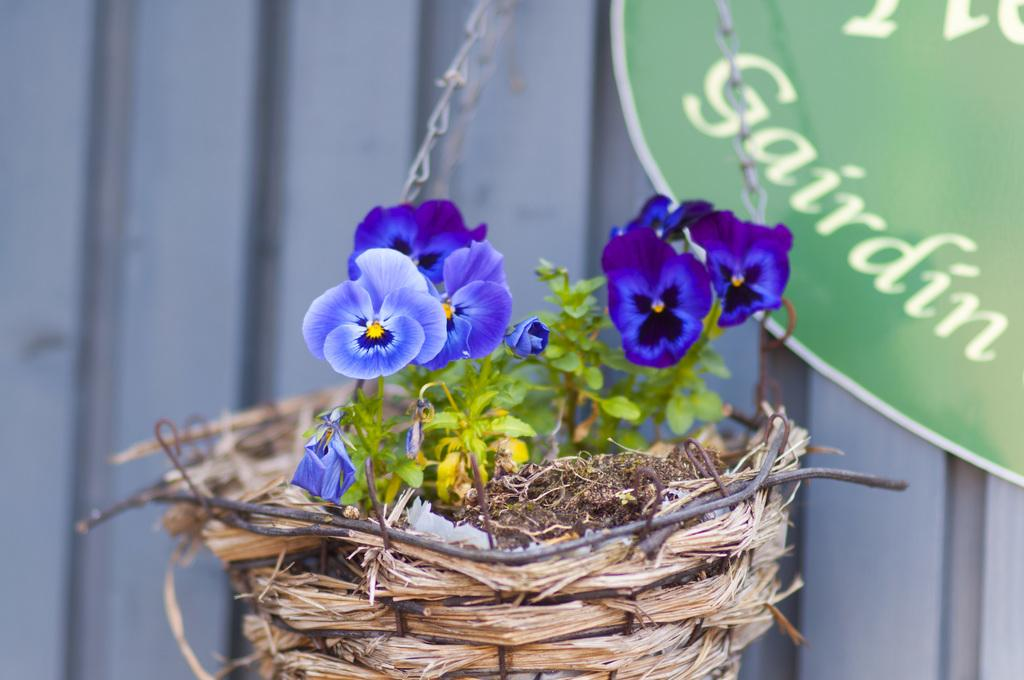What is hanging in the image? There is a hanging basket containing a plant in the image. What else can be seen in the top right of the image? There is a board in the top right of the image. Can you describe the background of the image? The background of the image is blurred. What is the acoustics like in the image? There is no information about the acoustics in the image, as it does not contain any elements related to sound or audio. 